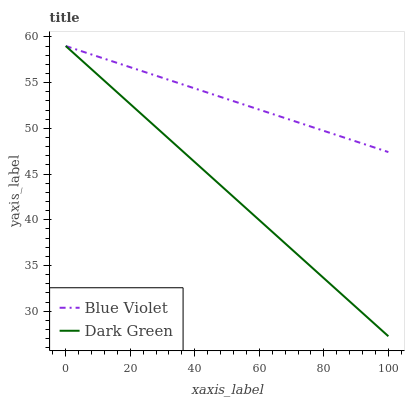Does Dark Green have the minimum area under the curve?
Answer yes or no. Yes. Does Blue Violet have the maximum area under the curve?
Answer yes or no. Yes. Does Dark Green have the maximum area under the curve?
Answer yes or no. No. Is Blue Violet the smoothest?
Answer yes or no. Yes. Is Dark Green the roughest?
Answer yes or no. Yes. Is Dark Green the smoothest?
Answer yes or no. No. Does Dark Green have the highest value?
Answer yes or no. Yes. Does Blue Violet intersect Dark Green?
Answer yes or no. Yes. Is Blue Violet less than Dark Green?
Answer yes or no. No. Is Blue Violet greater than Dark Green?
Answer yes or no. No. 